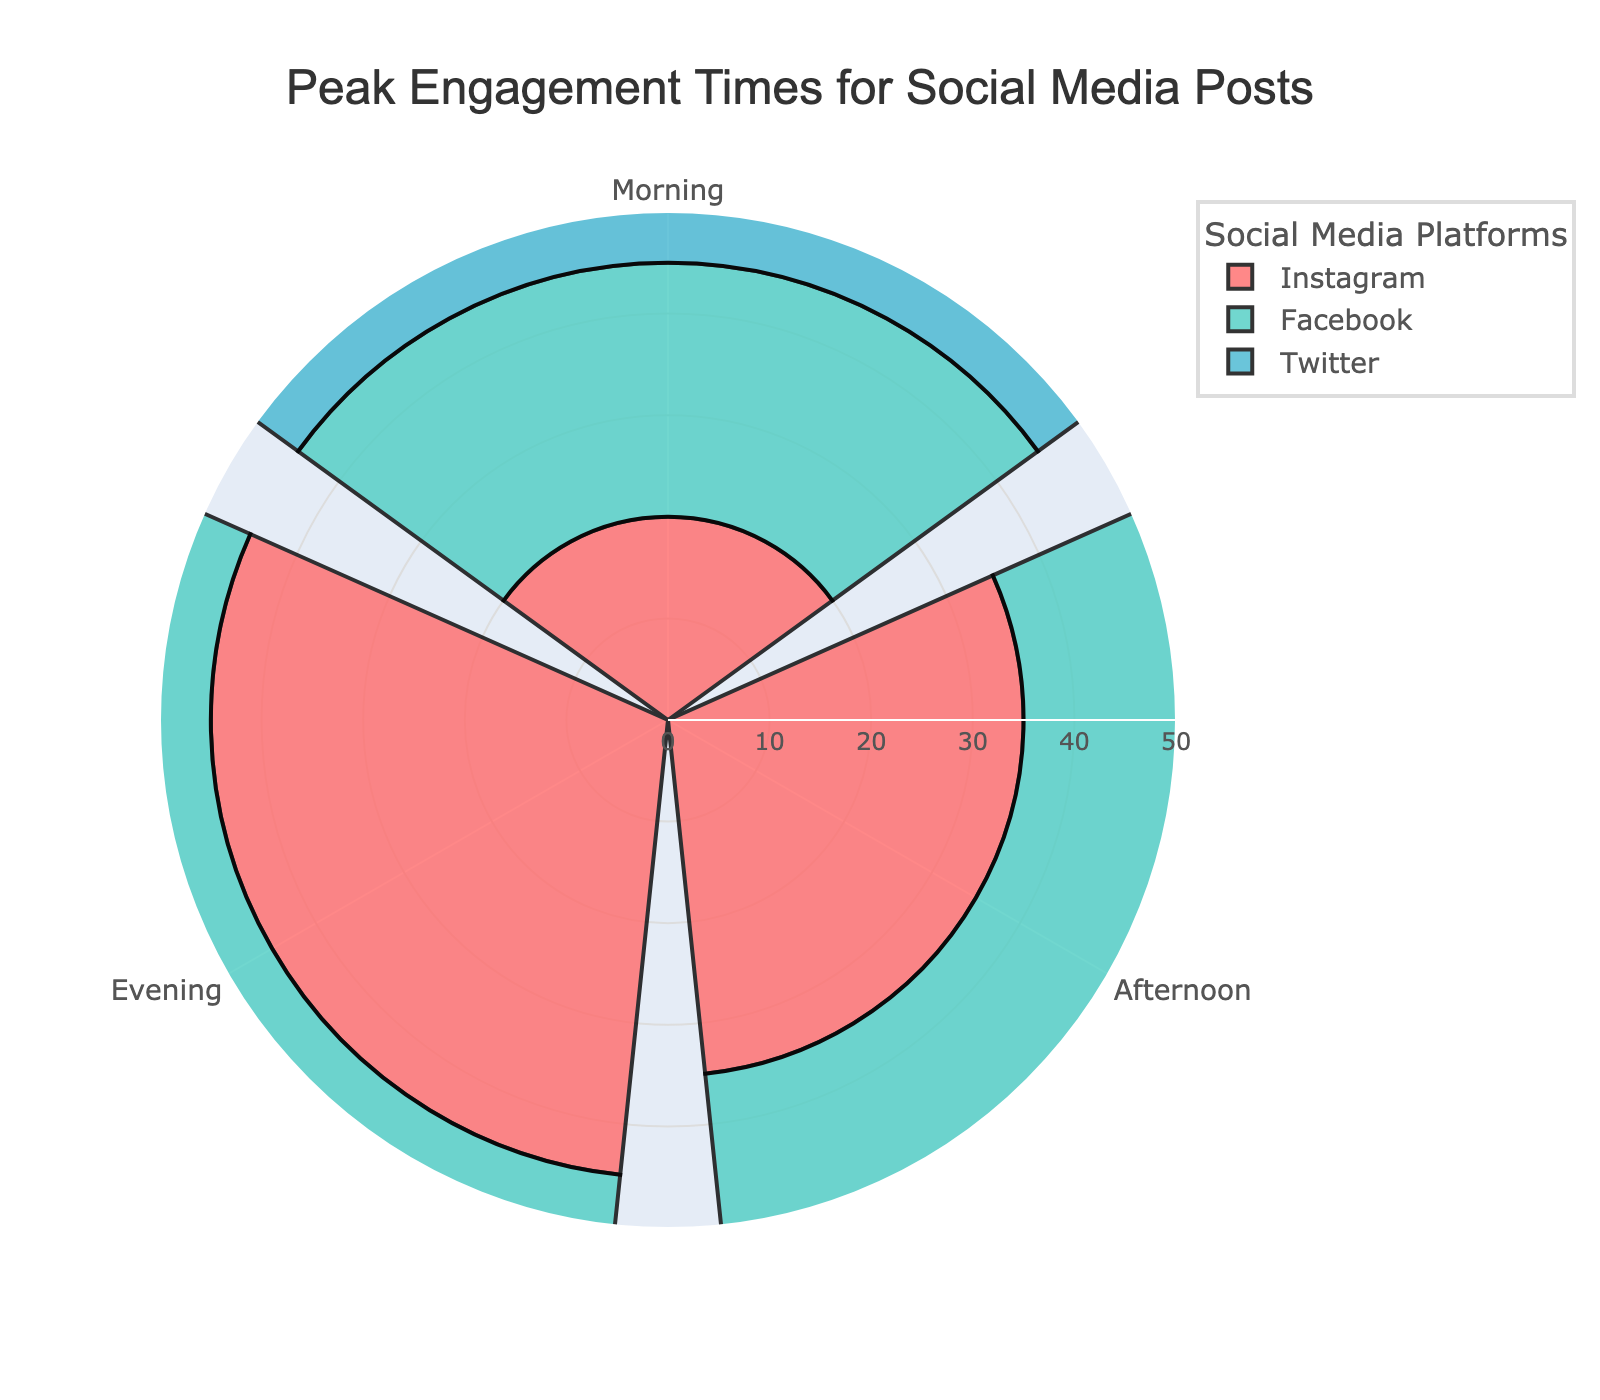What's the title of the figure? The title is displayed at the top of the figure, centered and in large font. It typically summarizes the content of the chart.
Answer: Peak Engagement Times for Social Media Posts How many platforms are represented in the chart? The legend shows the social media platforms represented. Each color in the legend corresponds to a platform.
Answer: 3 Which platform has the highest engagement in the morning? Look at the morning section of the rose chart and compare the lengths of the bars for each platform. The longest bar indicates the highest engagement.
Answer: Twitter Which time period shows the highest engagement for Instagram? Examine the length of the Instagram bars in each time period. The longest bar indicates the highest engagement.
Answer: Evening What is the total engagement for Facebook throughout the day? Look at the Facebook bars for morning, afternoon, and evening. Sum the lengths to get the total engagement. 25 (Morning) + 40 (Afternoon) + 35 (Evening) = 100.
Answer: 100 Which time period has the lowest engagement for all platforms? Check the bars for each platform in each time period and find the time period where the total lengths of the bars are the shortest.
Answer: Morning What is the difference in engagement between Facebook in the afternoon and Twitter in the morning? Find the lengths of the bars for Facebook in the afternoon and Twitter in the morning, then subtract the shorter value from the longer one. Facebook (Afternoon) = 40, Twitter (Morning) = 30. 40 - 30 = 10.
Answer: 10 Which platform has the most consistent engagement across all time periods? Look at the variance of the bar lengths for each platform across morning, afternoon, and evening. The platform with the least variance or most similar lengths has the most consistent engagement.
Answer: Facebook Is the engagement for Instagram higher in the afternoon or evening? Compare the lengths of the Instagram bars for afternoon and evening.
Answer: Evening How does Twitter's morning engagement compare to its evening engagement? Compare the lengths of the Twitter bars for morning and evening. Morning = 30, Evening = 45.
Answer: Evening is higher 